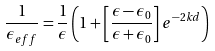<formula> <loc_0><loc_0><loc_500><loc_500>\frac { 1 } { { \epsilon _ { e f f } } } = \frac { 1 } { \epsilon } \left ( 1 + \left [ \frac { \epsilon - \epsilon _ { 0 } } { \epsilon + \epsilon _ { 0 } } \right ] e ^ { - 2 k d } \right )</formula> 